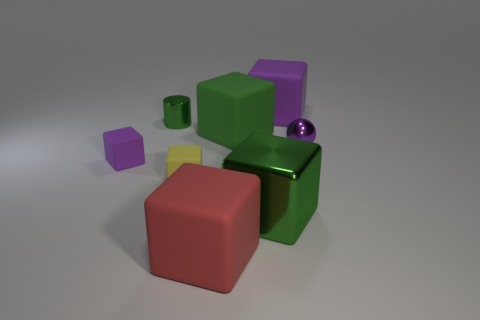There is a cylinder; does it have the same color as the metallic thing that is in front of the tiny purple matte object?
Provide a succinct answer. Yes. There is a tiny object to the left of the shiny cylinder; what is its color?
Make the answer very short. Purple. The large rubber object that is the same color as the sphere is what shape?
Offer a very short reply. Cube. What number of green blocks have the same size as the purple metal sphere?
Provide a short and direct response. 0. There is a green thing to the left of the yellow matte cube; is its shape the same as the tiny metal object right of the yellow matte cube?
Make the answer very short. No. What is the material of the green block in front of the shiny object on the right side of the purple rubber thing on the right side of the small purple block?
Your answer should be very brief. Metal. There is a green shiny thing that is the same size as the yellow rubber object; what is its shape?
Offer a very short reply. Cylinder. Is there a large metal object that has the same color as the tiny metal cylinder?
Your response must be concise. Yes. What size is the green matte block?
Your answer should be very brief. Large. Is the tiny purple cube made of the same material as the tiny green object?
Offer a very short reply. No. 